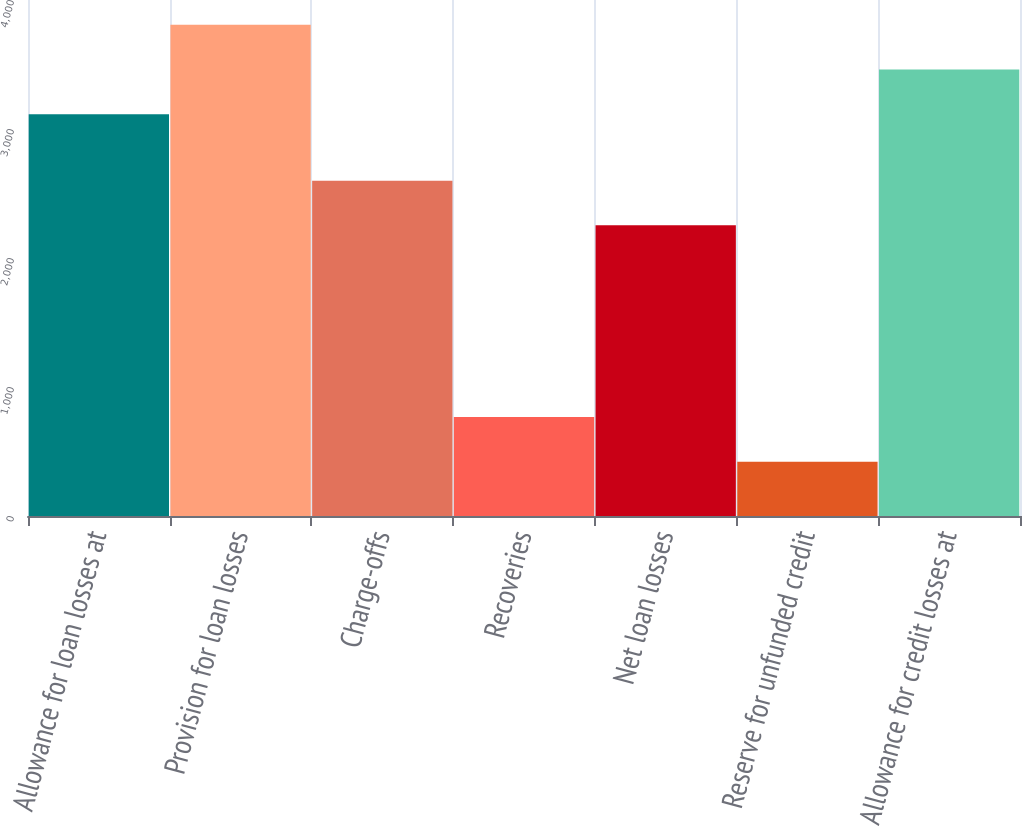Convert chart to OTSL. <chart><loc_0><loc_0><loc_500><loc_500><bar_chart><fcel>Allowance for loan losses at<fcel>Provision for loan losses<fcel>Charge-offs<fcel>Recoveries<fcel>Net loan losses<fcel>Reserve for unfunded credit<fcel>Allowance for credit losses at<nl><fcel>3114<fcel>3807.4<fcel>2599.7<fcel>767.4<fcel>2253<fcel>420.7<fcel>3460.7<nl></chart> 